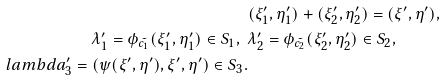<formula> <loc_0><loc_0><loc_500><loc_500>& ( \xi _ { 1 } ^ { \prime } , \eta _ { 1 } ^ { \prime } ) + ( \xi _ { 2 } ^ { \prime } , \eta _ { 2 } ^ { \prime } ) = ( \xi ^ { \prime } , \eta ^ { \prime } ) , \\ \lambda _ { 1 } ^ { \prime } = \phi _ { \tilde { c _ { 1 } } } ( \xi _ { 1 } ^ { \prime } , \eta _ { 1 } ^ { \prime } ) \in S _ { 1 } , \ \ & \lambda _ { 2 } ^ { \prime } = \phi _ { \tilde { c _ { 2 } } } ( \xi _ { 2 } ^ { \prime } , \eta _ { 2 } ^ { \prime } ) \in S _ { 2 } , \ \\ l a m b d a _ { 3 } ^ { \prime } = ( \psi ( \xi ^ { \prime } , \eta ^ { \prime } ) , \xi ^ { \prime } , \eta ^ { \prime } ) \in S _ { 3 } .</formula> 